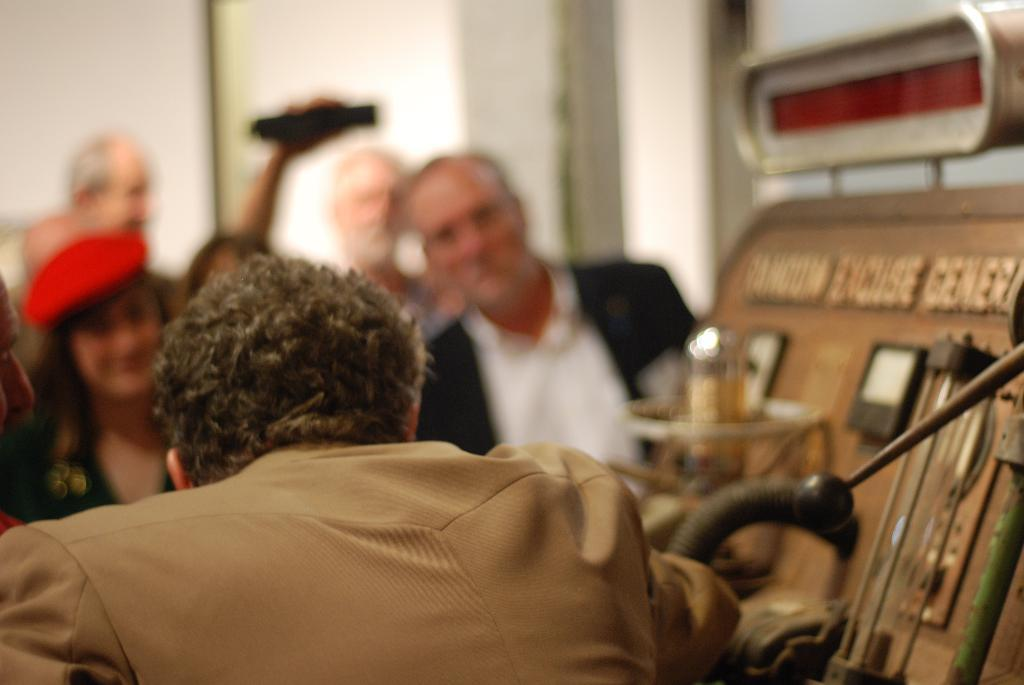Who or what is present in the image? There are people in the image. What can be seen on the right side of the image? There is a generator board with text in the image. How would you describe the background of the image? The background of the image is blurred. How many dimes can be seen on the ship in the image? There is no ship or dimes present in the image. What act are the people performing in the image? The facts provided do not give any information about the people's actions or activities in the image. 